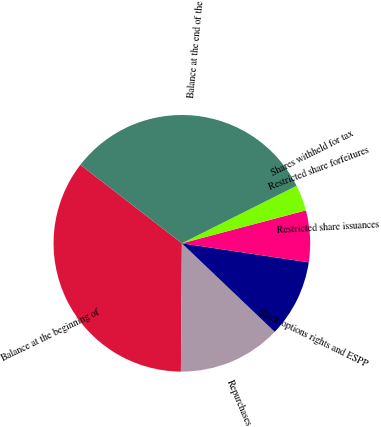Convert chart to OTSL. <chart><loc_0><loc_0><loc_500><loc_500><pie_chart><fcel>Balance at the beginning of<fcel>Repurchases<fcel>Stock options rights and ESPP<fcel>Restricted share issuances<fcel>Restricted share forfeitures<fcel>Shares withheld for tax<fcel>Balance at the end of the<nl><fcel>35.36%<fcel>13.0%<fcel>9.75%<fcel>6.5%<fcel>3.26%<fcel>0.01%<fcel>32.12%<nl></chart> 